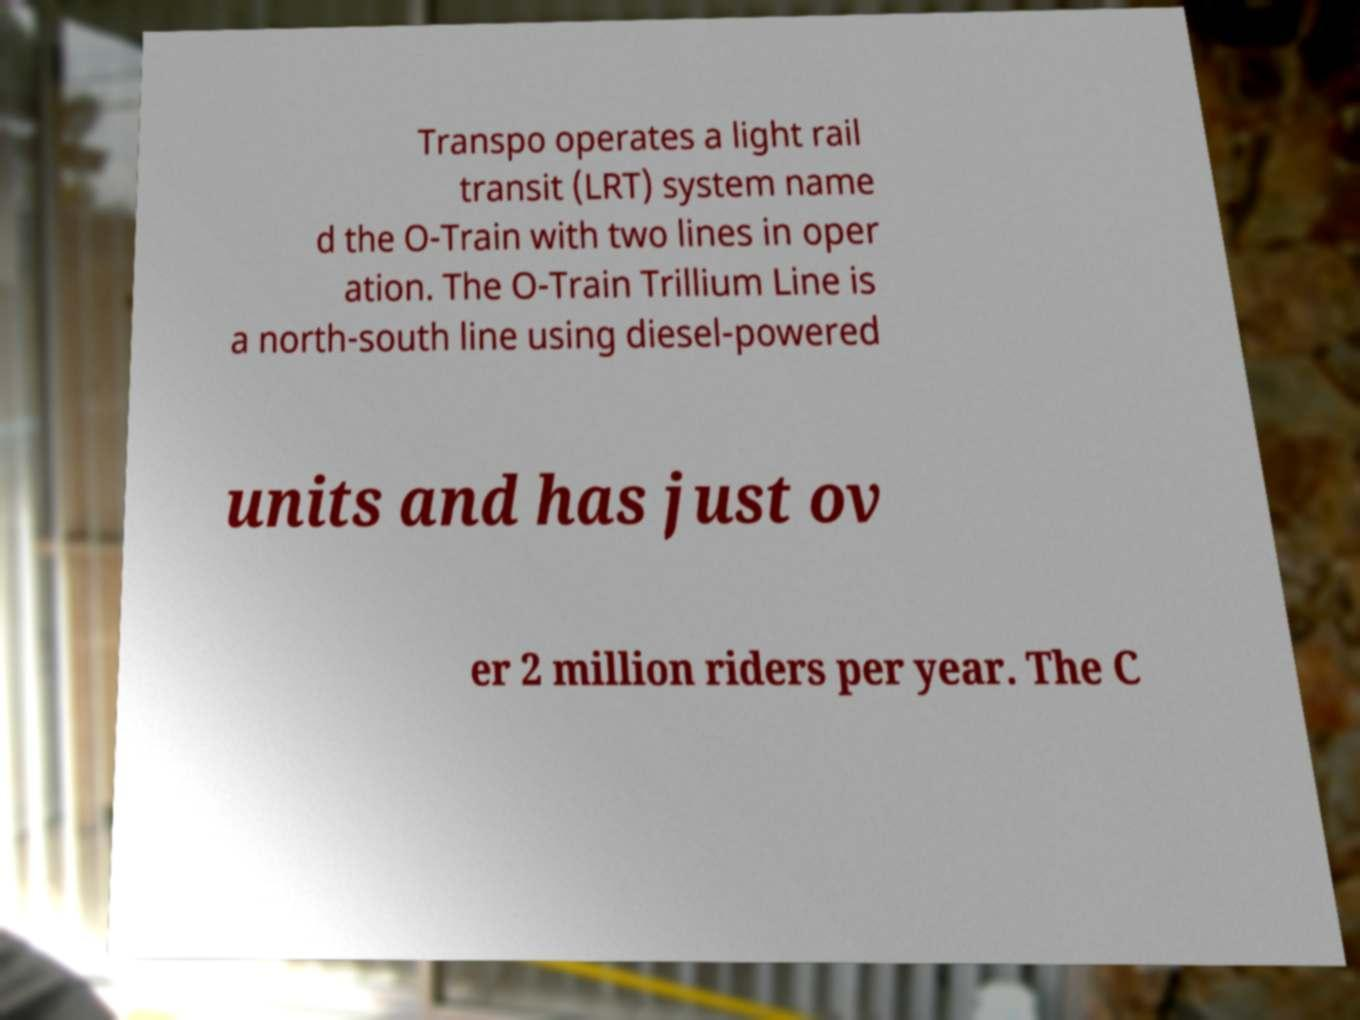What messages or text are displayed in this image? I need them in a readable, typed format. Transpo operates a light rail transit (LRT) system name d the O-Train with two lines in oper ation. The O-Train Trillium Line is a north-south line using diesel-powered units and has just ov er 2 million riders per year. The C 